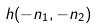<formula> <loc_0><loc_0><loc_500><loc_500>h ( - n _ { 1 } , - n _ { 2 } )</formula> 